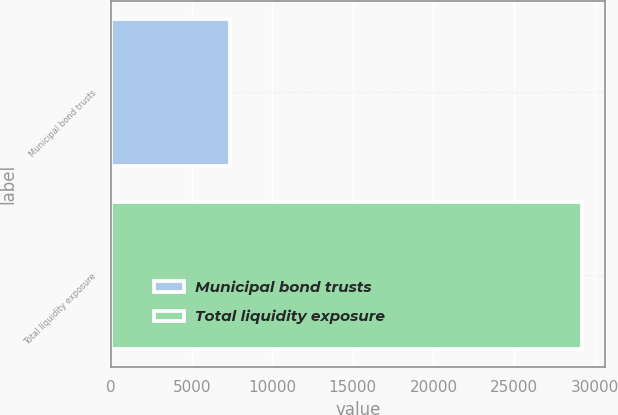Convert chart. <chart><loc_0><loc_0><loc_500><loc_500><bar_chart><fcel>Municipal bond trusts<fcel>Total liquidity exposure<nl><fcel>7359<fcel>29206<nl></chart> 